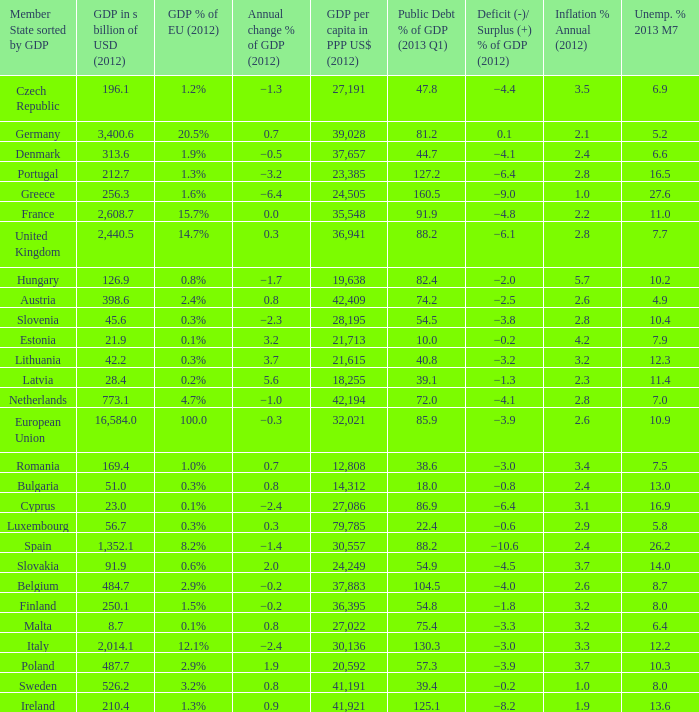Could you parse the entire table? {'header': ['Member State sorted by GDP', 'GDP in s billion of USD (2012)', 'GDP % of EU (2012)', 'Annual change % of GDP (2012)', 'GDP per capita in PPP US$ (2012)', 'Public Debt % of GDP (2013 Q1)', 'Deficit (-)/ Surplus (+) % of GDP (2012)', 'Inflation % Annual (2012)', 'Unemp. % 2013 M7'], 'rows': [['Czech Republic', '196.1', '1.2%', '−1.3', '27,191', '47.8', '−4.4', '3.5', '6.9'], ['Germany', '3,400.6', '20.5%', '0.7', '39,028', '81.2', '0.1', '2.1', '5.2'], ['Denmark', '313.6', '1.9%', '−0.5', '37,657', '44.7', '−4.1', '2.4', '6.6'], ['Portugal', '212.7', '1.3%', '−3.2', '23,385', '127.2', '−6.4', '2.8', '16.5'], ['Greece', '256.3', '1.6%', '−6.4', '24,505', '160.5', '−9.0', '1.0', '27.6'], ['France', '2,608.7', '15.7%', '0.0', '35,548', '91.9', '−4.8', '2.2', '11.0'], ['United Kingdom', '2,440.5', '14.7%', '0.3', '36,941', '88.2', '−6.1', '2.8', '7.7'], ['Hungary', '126.9', '0.8%', '−1.7', '19,638', '82.4', '−2.0', '5.7', '10.2'], ['Austria', '398.6', '2.4%', '0.8', '42,409', '74.2', '−2.5', '2.6', '4.9'], ['Slovenia', '45.6', '0.3%', '−2.3', '28,195', '54.5', '−3.8', '2.8', '10.4'], ['Estonia', '21.9', '0.1%', '3.2', '21,713', '10.0', '−0.2', '4.2', '7.9'], ['Lithuania', '42.2', '0.3%', '3.7', '21,615', '40.8', '−3.2', '3.2', '12.3'], ['Latvia', '28.4', '0.2%', '5.6', '18,255', '39.1', '−1.3', '2.3', '11.4'], ['Netherlands', '773.1', '4.7%', '−1.0', '42,194', '72.0', '−4.1', '2.8', '7.0'], ['European Union', '16,584.0', '100.0', '−0.3', '32,021', '85.9', '−3.9', '2.6', '10.9'], ['Romania', '169.4', '1.0%', '0.7', '12,808', '38.6', '−3.0', '3.4', '7.5'], ['Bulgaria', '51.0', '0.3%', '0.8', '14,312', '18.0', '−0.8', '2.4', '13.0'], ['Cyprus', '23.0', '0.1%', '−2.4', '27,086', '86.9', '−6.4', '3.1', '16.9'], ['Luxembourg', '56.7', '0.3%', '0.3', '79,785', '22.4', '−0.6', '2.9', '5.8'], ['Spain', '1,352.1', '8.2%', '−1.4', '30,557', '88.2', '−10.6', '2.4', '26.2'], ['Slovakia', '91.9', '0.6%', '2.0', '24,249', '54.9', '−4.5', '3.7', '14.0'], ['Belgium', '484.7', '2.9%', '−0.2', '37,883', '104.5', '−4.0', '2.6', '8.7'], ['Finland', '250.1', '1.5%', '−0.2', '36,395', '54.8', '−1.8', '3.2', '8.0'], ['Malta', '8.7', '0.1%', '0.8', '27,022', '75.4', '−3.3', '3.2', '6.4'], ['Italy', '2,014.1', '12.1%', '−2.4', '30,136', '130.3', '−3.0', '3.3', '12.2'], ['Poland', '487.7', '2.9%', '1.9', '20,592', '57.3', '−3.9', '3.7', '10.3'], ['Sweden', '526.2', '3.2%', '0.8', '41,191', '39.4', '−0.2', '1.0', '8.0'], ['Ireland', '210.4', '1.3%', '0.9', '41,921', '125.1', '−8.2', '1.9', '13.6']]} What is the average public debt % of GDP in 2013 Q1 of the country with a member slate sorted by GDP of Czech Republic and a GDP per capita in PPP US dollars in 2012 greater than 27,191? None. 